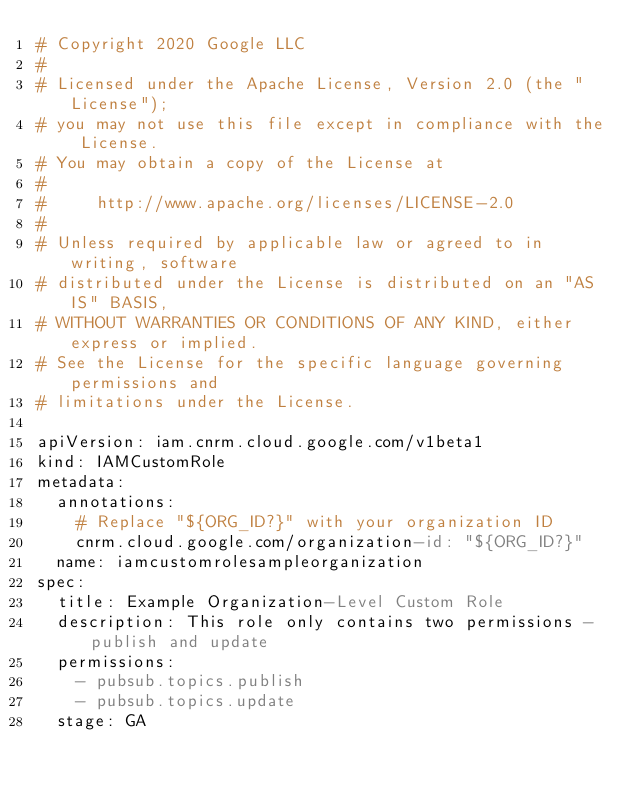Convert code to text. <code><loc_0><loc_0><loc_500><loc_500><_YAML_># Copyright 2020 Google LLC
#
# Licensed under the Apache License, Version 2.0 (the "License");
# you may not use this file except in compliance with the License.
# You may obtain a copy of the License at
#
#     http://www.apache.org/licenses/LICENSE-2.0
#
# Unless required by applicable law or agreed to in writing, software
# distributed under the License is distributed on an "AS IS" BASIS,
# WITHOUT WARRANTIES OR CONDITIONS OF ANY KIND, either express or implied.
# See the License for the specific language governing permissions and
# limitations under the License.

apiVersion: iam.cnrm.cloud.google.com/v1beta1
kind: IAMCustomRole
metadata:
  annotations:
    # Replace "${ORG_ID?}" with your organization ID
    cnrm.cloud.google.com/organization-id: "${ORG_ID?}"
  name: iamcustomrolesampleorganization
spec:
  title: Example Organization-Level Custom Role
  description: This role only contains two permissions - publish and update
  permissions:
    - pubsub.topics.publish
    - pubsub.topics.update
  stage: GA
</code> 